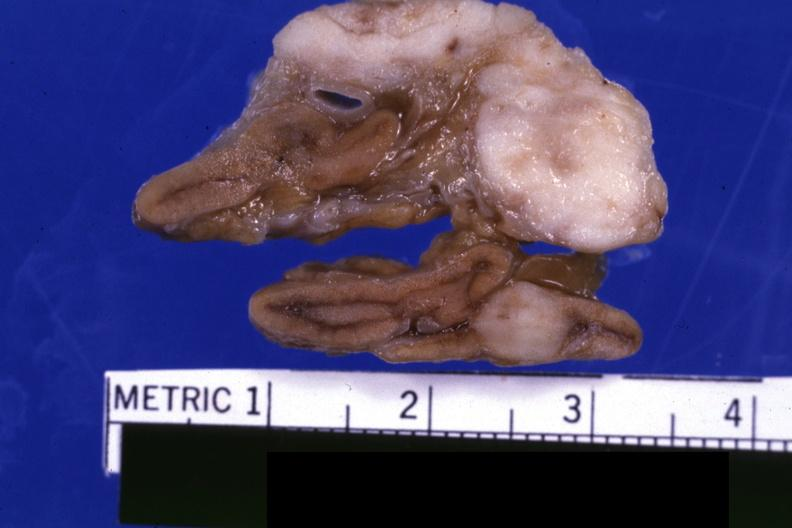what is present?
Answer the question using a single word or phrase. Adrenal 